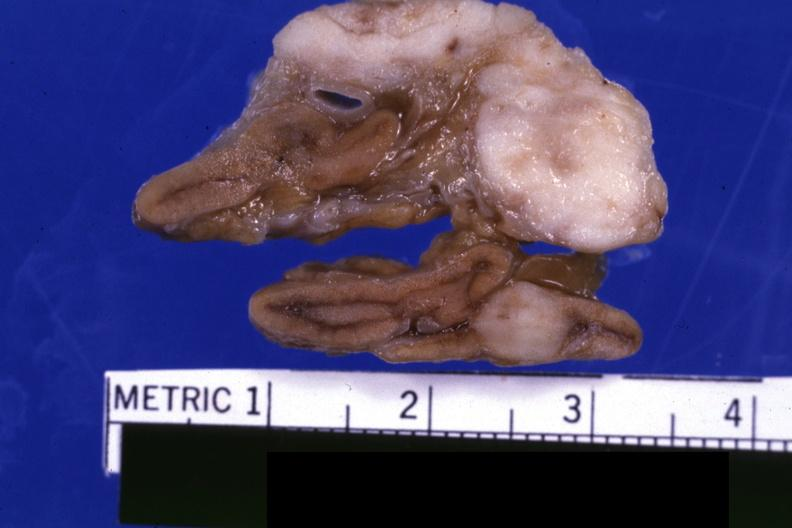what is present?
Answer the question using a single word or phrase. Adrenal 